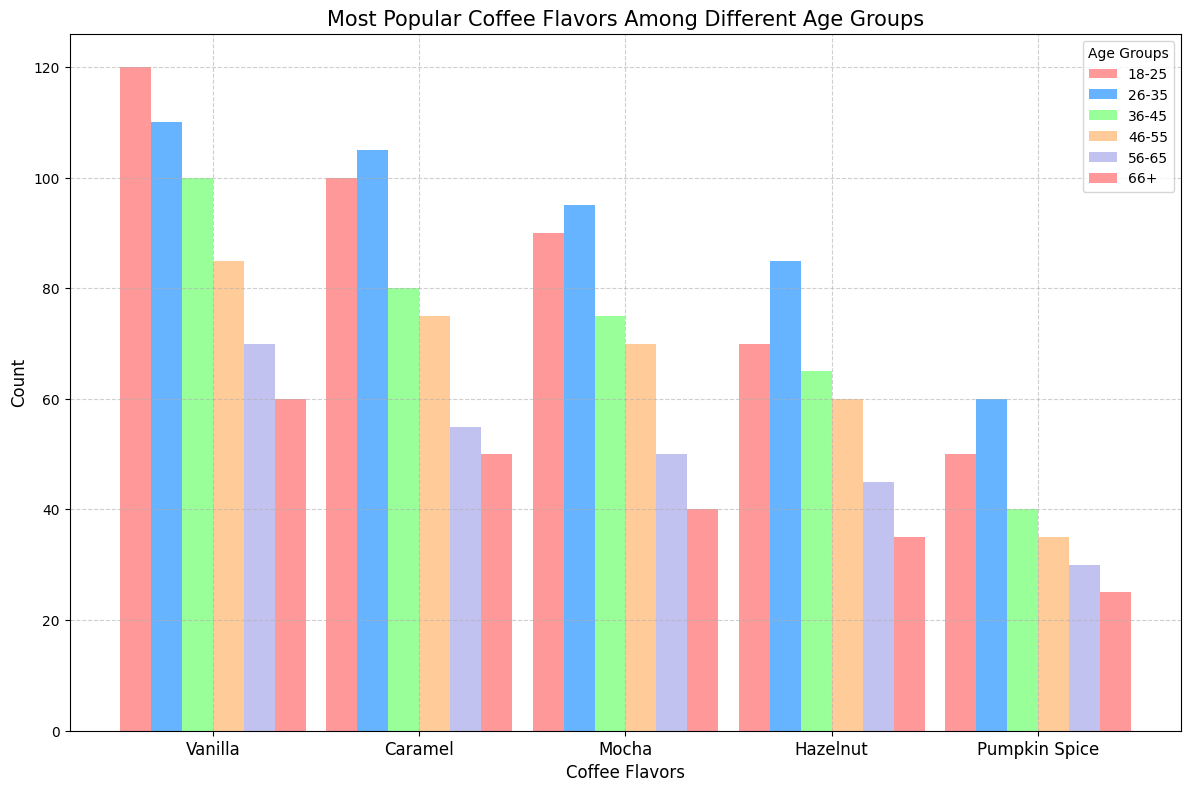What is the most popular coffee flavor among the 18-25 age group? The bar chart shows that Vanilla has the highest count among the 18-25 age group, with a frequency of 120.
Answer: Vanilla Which age group has the highest count for Pumpkin Spice flavor? Referring to the bars representing Pumpkin Spice flavor, the 26-35 age group has the highest count with a frequency of 60.
Answer: 26-35 How many total counts of Mocha flavor are there across all age groups? The counts for Mocha flavor across all age groups are: 90 (18-25), 95 (26-35), 75 (36-45), 70 (46-55), 50 (56-65), and 40 (66+). Adding them up gives 90 + 95 + 75 + 70 + 50 + 40 = 420.
Answer: 420 Which flavor has the lowest average count across all age groups? To find the lowest average count, calculate the average count for each flavor: Vanilla ([(120+110+100+85+70+60)/6]), Caramel ([(100+105+80+75+55+50)/6]), Mocha ([(90+95+75+70+50+40)/6]), Hazelnut ([(70+85+65+60+45+35)/6]), Pumpkin Spice ([(50+60+40+35+30+25)/6]). Comparing these averages, Pumpkin Spice has the lowest average.
Answer: Pumpkin Spice Does any flavor have an increasing trend in popularity as age increases? Looking at the bar heights for each flavor across age groups, none of the flavors show a consistent increase as the age group increases. Instead, most flavors show a decline or fluctuation.
Answer: No Which two age groups have the closest counts for Caramel flavor? Comparing the Caramel counts, the 18-25 age group has 100 and the 46-55 age group has 75. The closest counts are between the 26-35 and 36-45 age groups with 105 and 80 respectively, differing by 25.
Answer: 26-35 and 36-45 Which age group shows the highest variation in counts across all flavors? Calculate the range (difference between highest and lowest counts) for each age group: 18-25 (120-50=70), 26-35 (110-60=50), 36-45 (100-40=60), 46-55 (85-35=50), 56-65 (70-30=40), 66+ (60-25=35). The 18-25 age group shows the highest variation.
Answer: 18-25 What is the total count of coffee flavors for the age group 46-55? Add up the counts of all flavors for the 46-55 age group: Vanilla (85), Caramel (75), Mocha (70), Hazelnut (60), Pumpkin Spice (35). This gives a total of 85 + 75 + 70 + 60 + 35 = 325.
Answer: 325 What is the percentage difference of Vanilla flavor counts between the 18-25 and 66+ age groups? The counts for Vanilla flavor are 120 (18-25) and 60 (66+). The percentage difference is calculated as ((120-60) / 120) * 100 which equals 50%.
Answer: 50% 